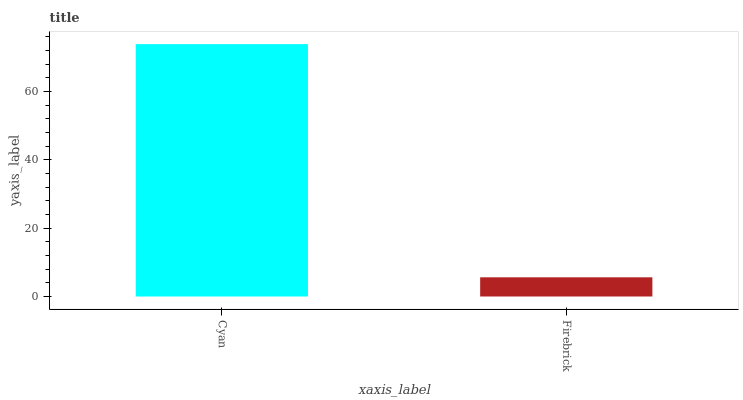Is Firebrick the maximum?
Answer yes or no. No. Is Cyan greater than Firebrick?
Answer yes or no. Yes. Is Firebrick less than Cyan?
Answer yes or no. Yes. Is Firebrick greater than Cyan?
Answer yes or no. No. Is Cyan less than Firebrick?
Answer yes or no. No. Is Cyan the high median?
Answer yes or no. Yes. Is Firebrick the low median?
Answer yes or no. Yes. Is Firebrick the high median?
Answer yes or no. No. Is Cyan the low median?
Answer yes or no. No. 